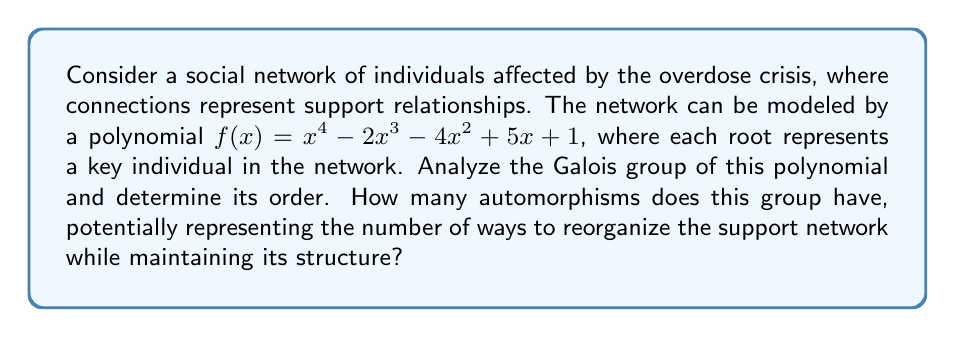Give your solution to this math problem. 1. First, we need to determine if the polynomial is irreducible over $\mathbb{Q}$. We can use Eisenstein's criterion with $p=5$:
   $5 | 1, 5 | -4, 5 | -2, 5 \nmid 1$
   $5^2 \nmid 1$
   Therefore, $f(x)$ is irreducible over $\mathbb{Q}$.

2. The degree of $f(x)$ is 4, so its Galois group is a subgroup of $S_4$.

3. To determine the exact Galois group, we need to find the discriminant:
   $\Delta = 2000 + 256 = 2256 = 2^4 \cdot 141$

4. Since $\Delta$ is not a perfect square, the Galois group must contain an odd permutation. This eliminates $A_4$ as a possibility.

5. The only subgroups of $S_4$ containing an odd permutation and of order divisible by 4 are $S_4$ itself and $D_4$ (the dihedral group of order 8).

6. To distinguish between these, we need to factor $f(x)$ modulo some primes:
   $f(x) \equiv x^4 + 3x^3 + x^2 + x + 1 \pmod{5}$
   This factors as $(x^2 + x + 2)(x^2 + 2x + 3) \pmod{5}$

7. The factorization pattern is (2,2), which is consistent with $S_4$ but not with $D_4$.

8. Therefore, the Galois group of $f(x)$ is $S_4$.

9. The order of $S_4$ is $4! = 24$.

Thus, there are 24 automorphisms in the Galois group, representing 24 ways to reorganize the support network while maintaining its algebraic structure.
Answer: 24 